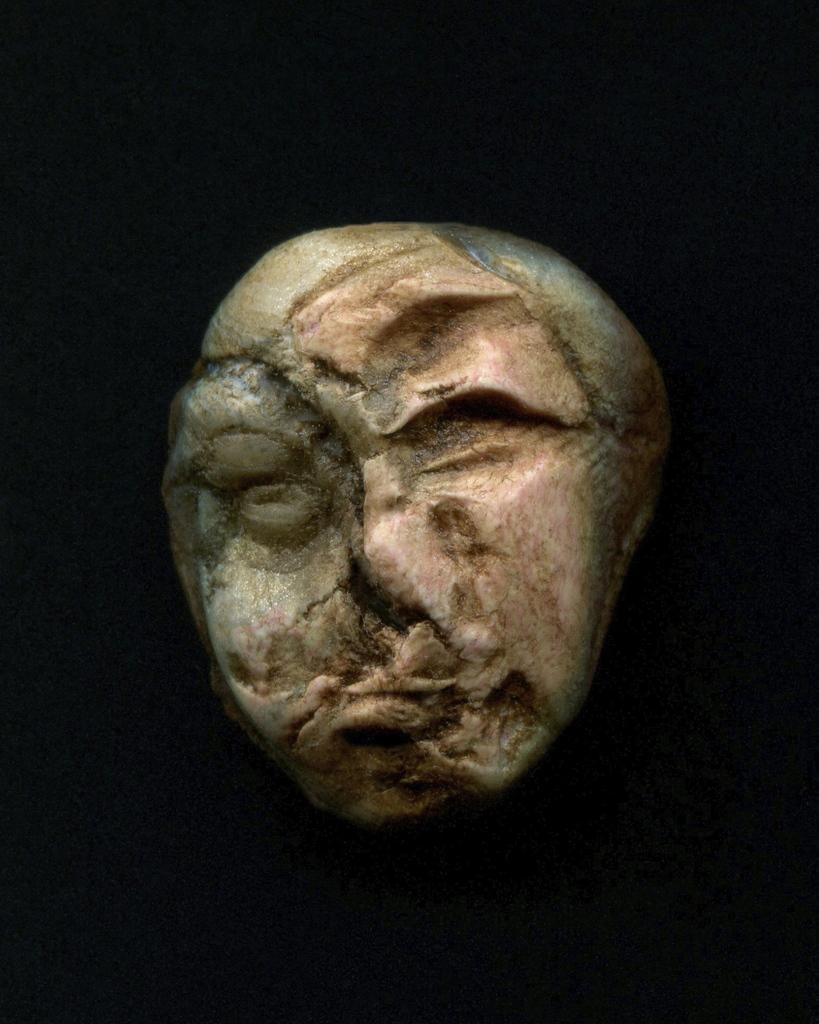Could you give a brief overview of what you see in this image? In the center of this picture we can see an object which seems to be the sculpture. The background of the image is very dark. 